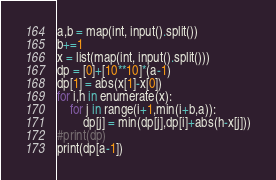<code> <loc_0><loc_0><loc_500><loc_500><_Python_>a,b = map(int, input().split())
b+=1
x = list(map(int, input().split()))
dp = [0]+[10**10]*(a-1)
dp[1] = abs(x[1]-x[0])
for i,h in enumerate(x):
    for j in range(i+1,min(i+b,a)):
        dp[j] = min(dp[j],dp[i]+abs(h-x[j]))
#print(dp)
print(dp[a-1])</code> 